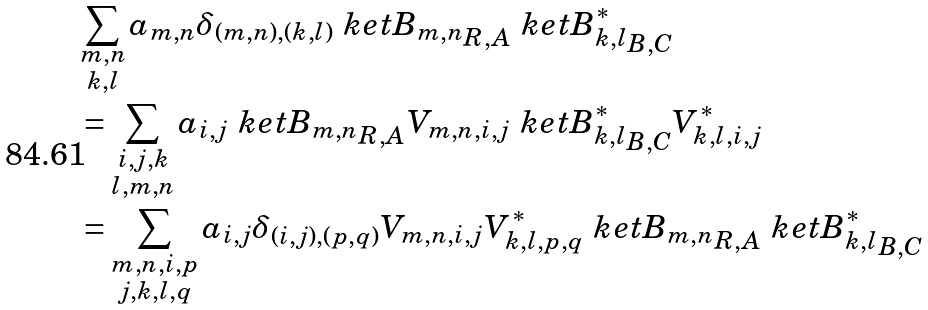<formula> <loc_0><loc_0><loc_500><loc_500>& \sum _ { \substack { m , n \\ k , l } } a _ { m , n } \delta _ { ( m , n ) , ( k , l ) } \ k e t { B _ { m , n } } _ { R , A } \ k e t { B _ { k , l } ^ { * } } _ { B , C } \\ & = \sum _ { \substack { i , j , k \\ l , m , n } } a _ { i , j } \ k e t { B _ { m , n } } _ { R , A } V _ { m , n , i , j } \ k e t { B _ { k , l } ^ { * } } _ { B , C } V ^ { * } _ { k , l , i , j } \\ & = \sum _ { \substack { m , n , i , p \\ j , k , l , q } } a _ { i , j } \delta _ { ( i , j ) , ( p , q ) } V _ { m , n , i , j } V ^ { * } _ { k , l , p , q } \ k e t { B _ { m , n } } _ { R , A } \ k e t { B _ { k , l } ^ { * } } _ { B , C }</formula> 